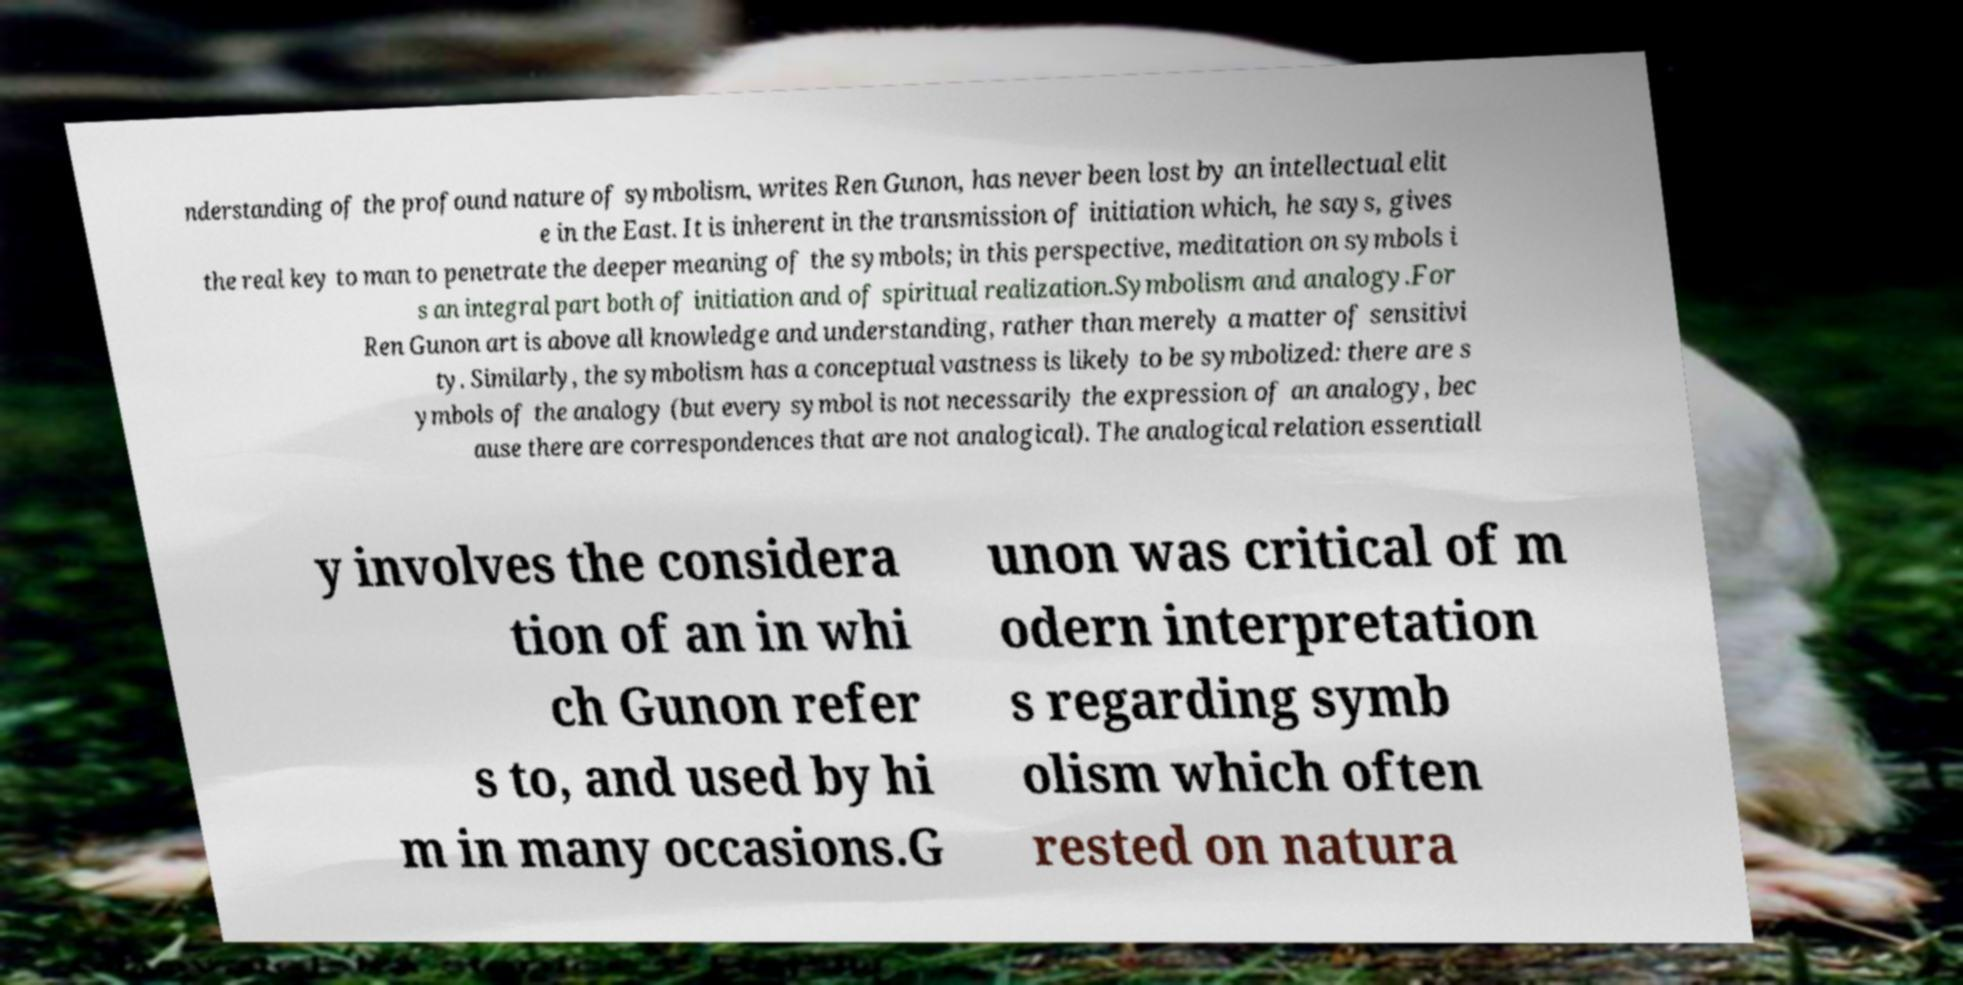Could you extract and type out the text from this image? nderstanding of the profound nature of symbolism, writes Ren Gunon, has never been lost by an intellectual elit e in the East. It is inherent in the transmission of initiation which, he says, gives the real key to man to penetrate the deeper meaning of the symbols; in this perspective, meditation on symbols i s an integral part both of initiation and of spiritual realization.Symbolism and analogy.For Ren Gunon art is above all knowledge and understanding, rather than merely a matter of sensitivi ty. Similarly, the symbolism has a conceptual vastness is likely to be symbolized: there are s ymbols of the analogy (but every symbol is not necessarily the expression of an analogy, bec ause there are correspondences that are not analogical). The analogical relation essentiall y involves the considera tion of an in whi ch Gunon refer s to, and used by hi m in many occasions.G unon was critical of m odern interpretation s regarding symb olism which often rested on natura 